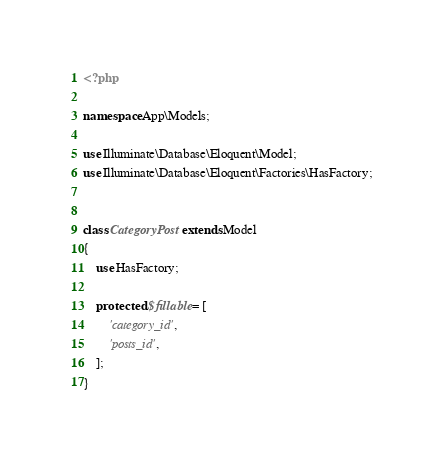Convert code to text. <code><loc_0><loc_0><loc_500><loc_500><_PHP_><?php

namespace App\Models;

use Illuminate\Database\Eloquent\Model;
use Illuminate\Database\Eloquent\Factories\HasFactory;


class CategoryPost extends Model
{
    use HasFactory;

    protected $fillable = [
        'category_id', 
        'posts_id',
    ];
}</code> 